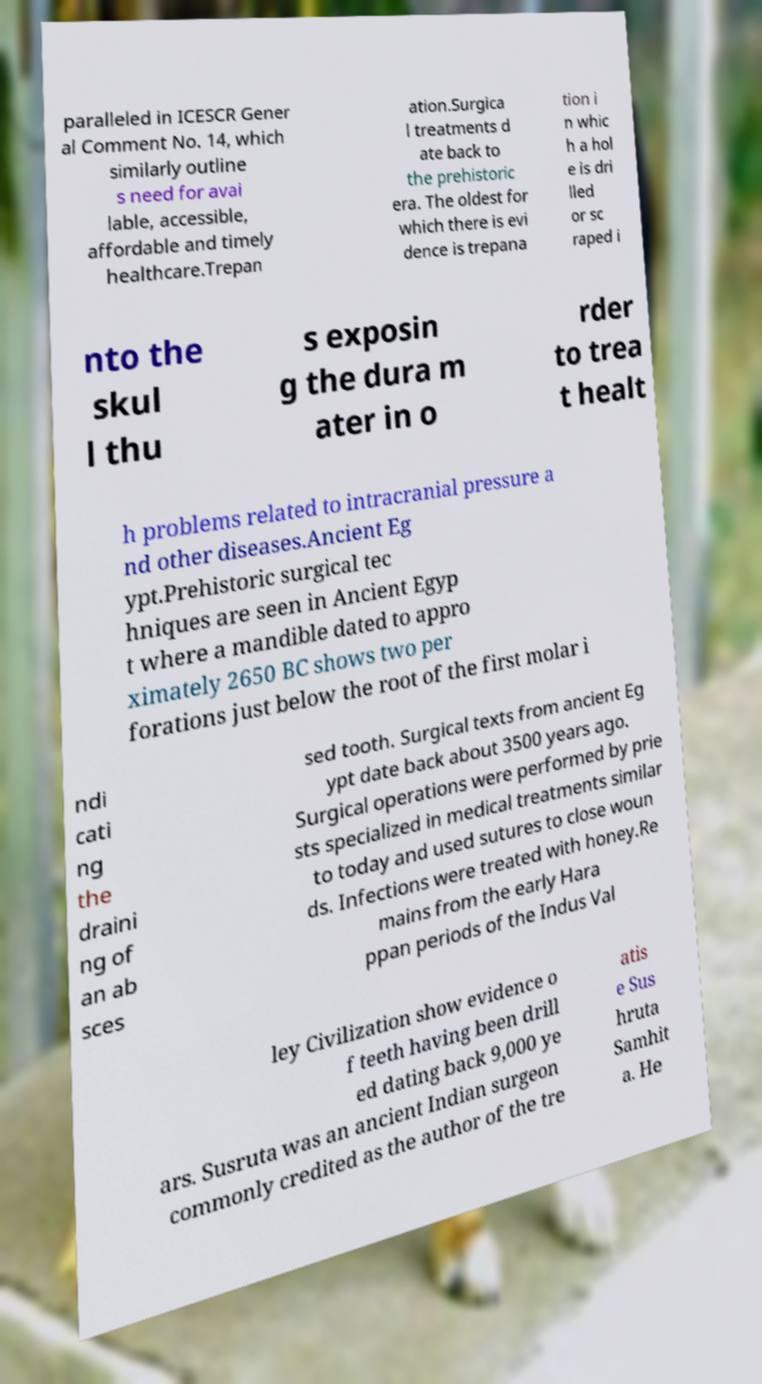There's text embedded in this image that I need extracted. Can you transcribe it verbatim? paralleled in ICESCR Gener al Comment No. 14, which similarly outline s need for avai lable, accessible, affordable and timely healthcare.Trepan ation.Surgica l treatments d ate back to the prehistoric era. The oldest for which there is evi dence is trepana tion i n whic h a hol e is dri lled or sc raped i nto the skul l thu s exposin g the dura m ater in o rder to trea t healt h problems related to intracranial pressure a nd other diseases.Ancient Eg ypt.Prehistoric surgical tec hniques are seen in Ancient Egyp t where a mandible dated to appro ximately 2650 BC shows two per forations just below the root of the first molar i ndi cati ng the draini ng of an ab sces sed tooth. Surgical texts from ancient Eg ypt date back about 3500 years ago. Surgical operations were performed by prie sts specialized in medical treatments similar to today and used sutures to close woun ds. Infections were treated with honey.Re mains from the early Hara ppan periods of the Indus Val ley Civilization show evidence o f teeth having been drill ed dating back 9,000 ye ars. Susruta was an ancient Indian surgeon commonly credited as the author of the tre atis e Sus hruta Samhit a. He 